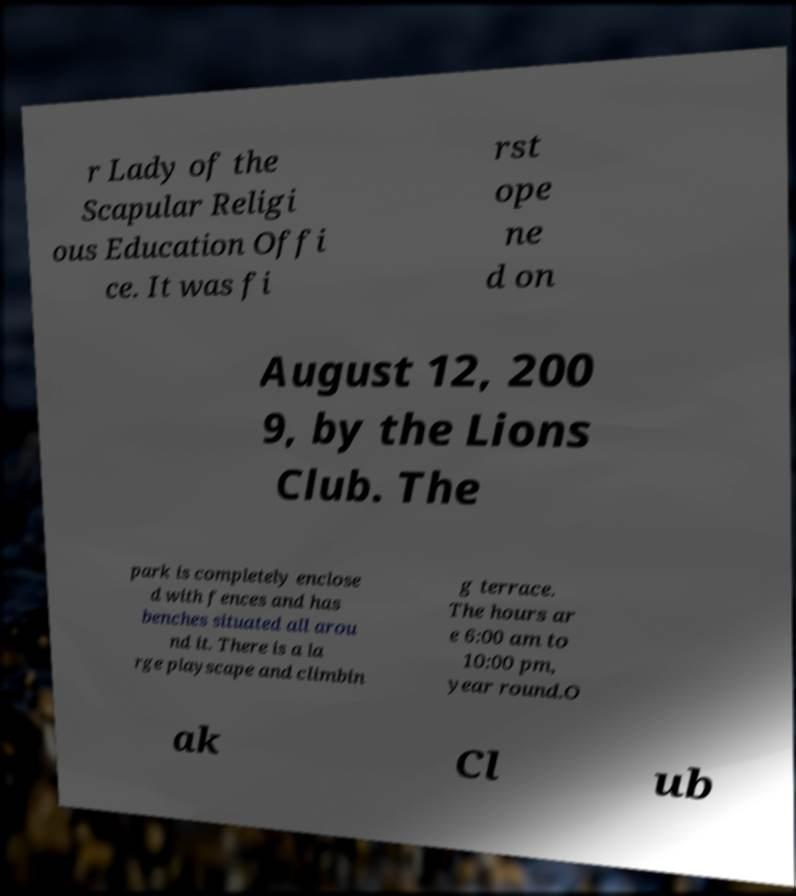Could you assist in decoding the text presented in this image and type it out clearly? r Lady of the Scapular Religi ous Education Offi ce. It was fi rst ope ne d on August 12, 200 9, by the Lions Club. The park is completely enclose d with fences and has benches situated all arou nd it. There is a la rge playscape and climbin g terrace. The hours ar e 6:00 am to 10:00 pm, year round.O ak Cl ub 